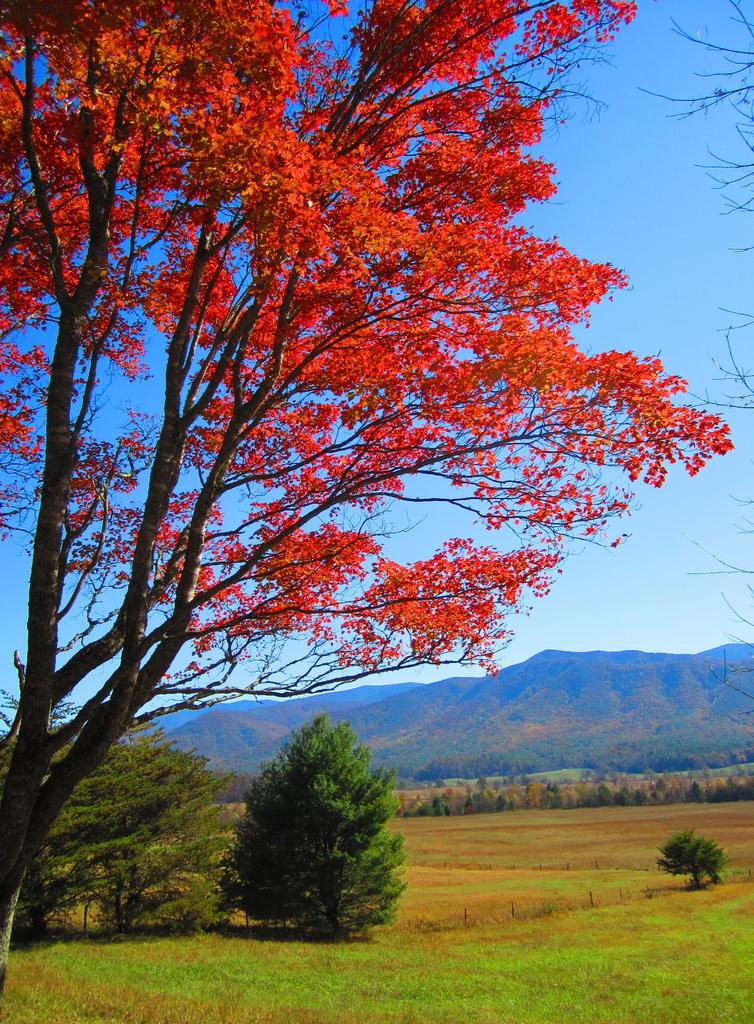What type of landscape is depicted in the image? There is a grassland in the image. What can be seen in the distance behind the grassland? There are trees and a mountain in the background of the image. What is visible in the sky in the image? The sky is visible in the background of the image. What type of prose can be heard in the image? There is no prose or any audible content in the image, as it is a still photograph. 